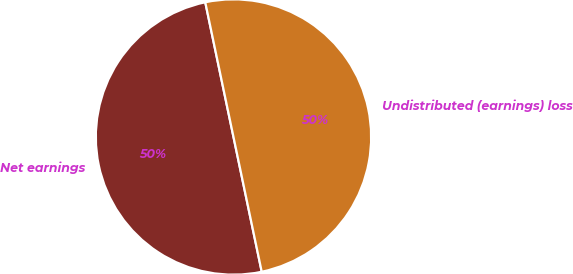Convert chart. <chart><loc_0><loc_0><loc_500><loc_500><pie_chart><fcel>Net earnings<fcel>Undistributed (earnings) loss<nl><fcel>50.0%<fcel>50.0%<nl></chart> 